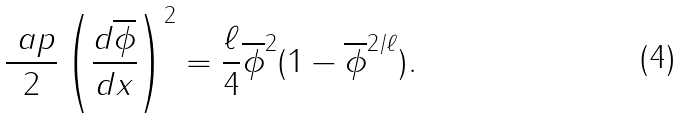<formula> <loc_0><loc_0><loc_500><loc_500>\frac { \ a p } { 2 } \left ( \frac { d \overline { \phi } } { d x } \right ) ^ { 2 } = \frac { \ell } { 4 } \overline { \phi } ^ { 2 } ( 1 - \overline { \phi } ^ { 2 / \ell } ) .</formula> 